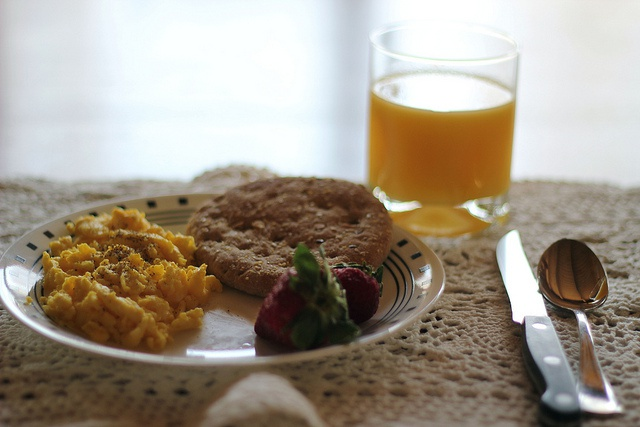Describe the objects in this image and their specific colors. I can see dining table in darkgray, maroon, and gray tones, cup in darkgray, olive, white, and tan tones, knife in darkgray, white, black, and gray tones, and spoon in darkgray, black, maroon, and gray tones in this image. 